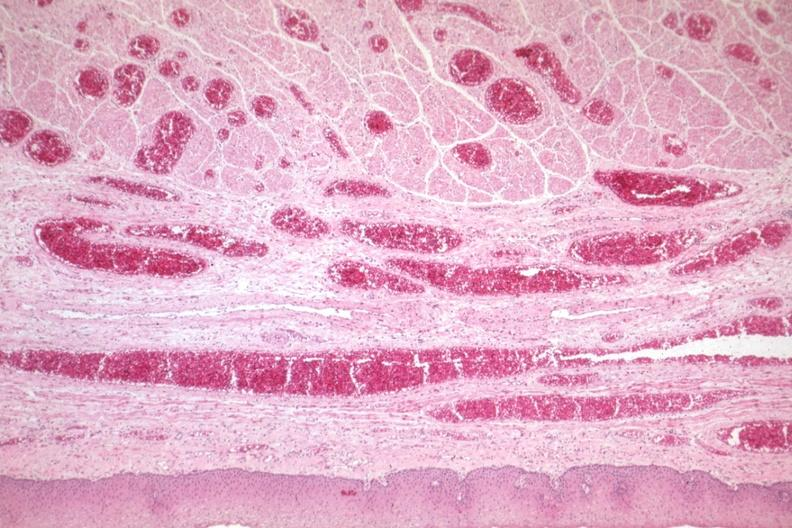what is present?
Answer the question using a single word or phrase. Varices 